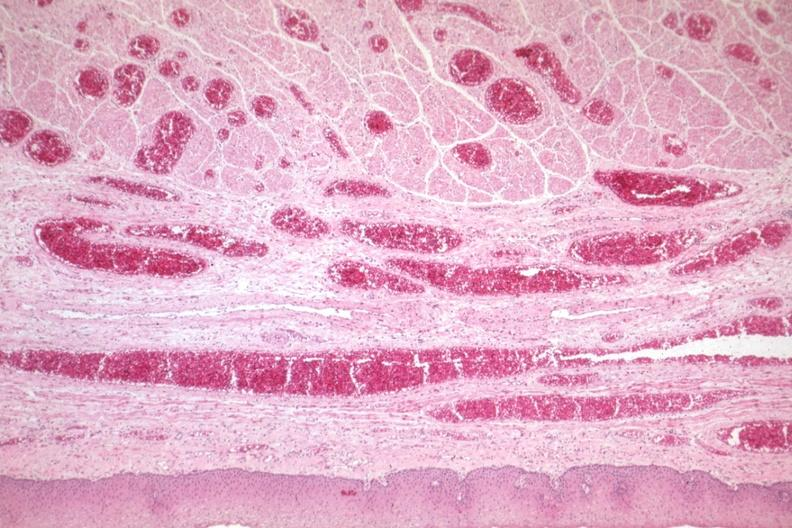what is present?
Answer the question using a single word or phrase. Varices 